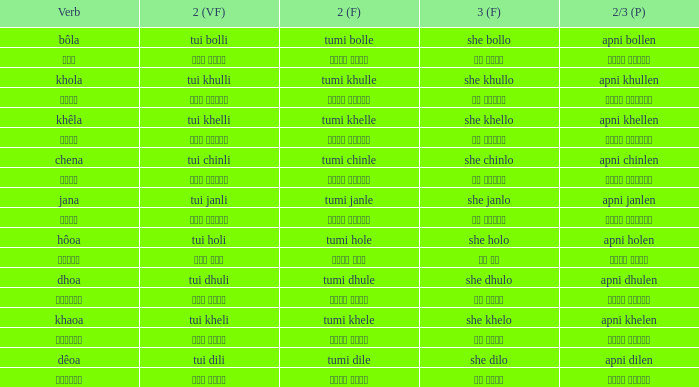Can you give me this table as a dict? {'header': ['Verb', '2 (VF)', '2 (F)', '3 (F)', '2/3 (P)'], 'rows': [['bôla', 'tui bolli', 'tumi bolle', 'she bollo', 'apni bollen'], ['বলা', 'তুই বললি', 'তুমি বললে', 'সে বললো', 'আপনি বললেন'], ['khola', 'tui khulli', 'tumi khulle', 'she khullo', 'apni khullen'], ['খোলা', 'তুই খুললি', 'তুমি খুললে', 'সে খুললো', 'আপনি খুললেন'], ['khêla', 'tui khelli', 'tumi khelle', 'she khello', 'apni khellen'], ['খেলে', 'তুই খেললি', 'তুমি খেললে', 'সে খেললো', 'আপনি খেললেন'], ['chena', 'tui chinli', 'tumi chinle', 'she chinlo', 'apni chinlen'], ['চেনা', 'তুই চিনলি', 'তুমি চিনলে', 'সে চিনলো', 'আপনি চিনলেন'], ['jana', 'tui janli', 'tumi janle', 'she janlo', 'apni janlen'], ['জানা', 'তুই জানলি', 'তুমি জানলে', 'সে জানলে', 'আপনি জানলেন'], ['hôoa', 'tui holi', 'tumi hole', 'she holo', 'apni holen'], ['হওয়া', 'তুই হলি', 'তুমি হলে', 'সে হল', 'আপনি হলেন'], ['dhoa', 'tui dhuli', 'tumi dhule', 'she dhulo', 'apni dhulen'], ['ধোওয়া', 'তুই ধুলি', 'তুমি ধুলে', 'সে ধুলো', 'আপনি ধুলেন'], ['khaoa', 'tui kheli', 'tumi khele', 'she khelo', 'apni khelen'], ['খাওয়া', 'তুই খেলি', 'তুমি খেলে', 'সে খেলো', 'আপনি খেলেন'], ['dêoa', 'tui dili', 'tumi dile', 'she dilo', 'apni dilen'], ['দেওয়া', 'তুই দিলি', 'তুমি দিলে', 'সে দিলো', 'আপনি দিলেন']]} What is the 2nd verb for chena? Tumi chinle. 